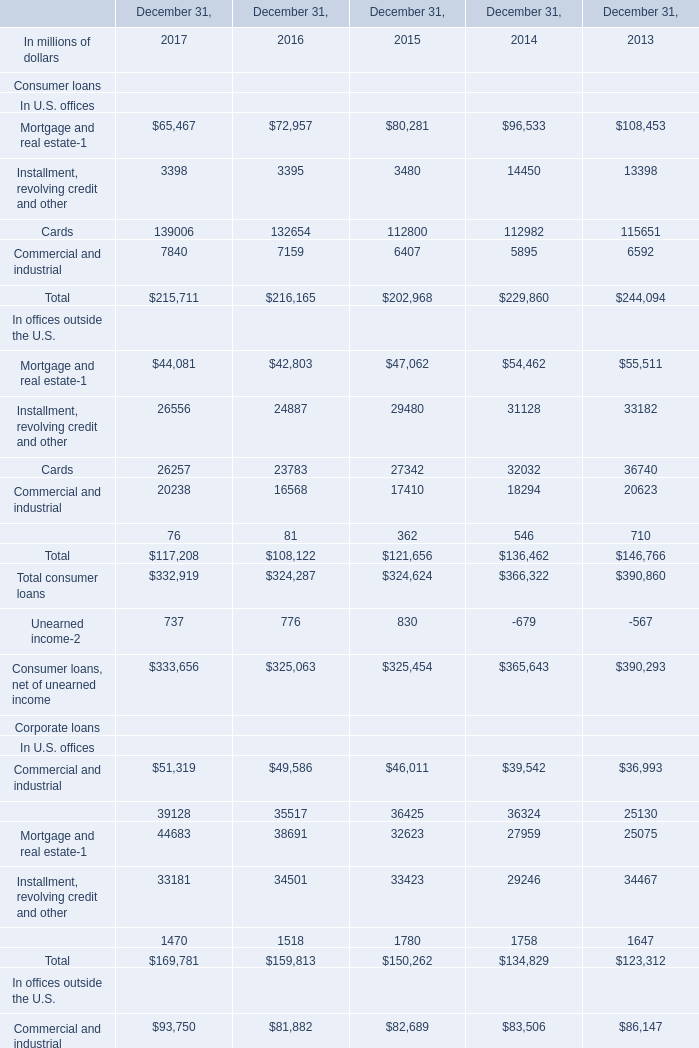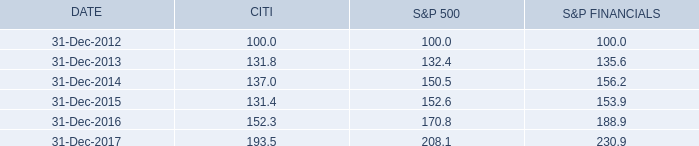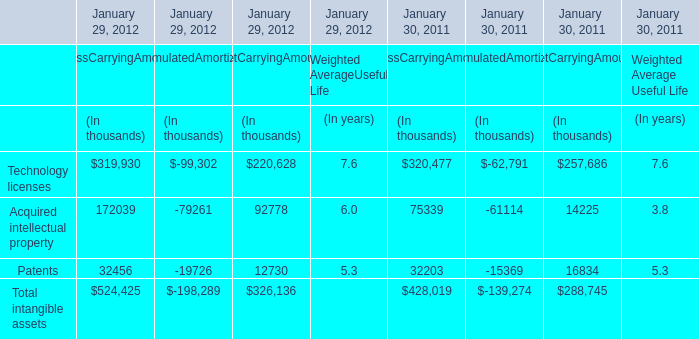What willTotal consumer loans be like in 2017 if it develops with the same increasing rate as current? (in million) 
Computations: ((1 + ((334141 - 300010) / 300010)) * 334141)
Answer: 372154.95444. 